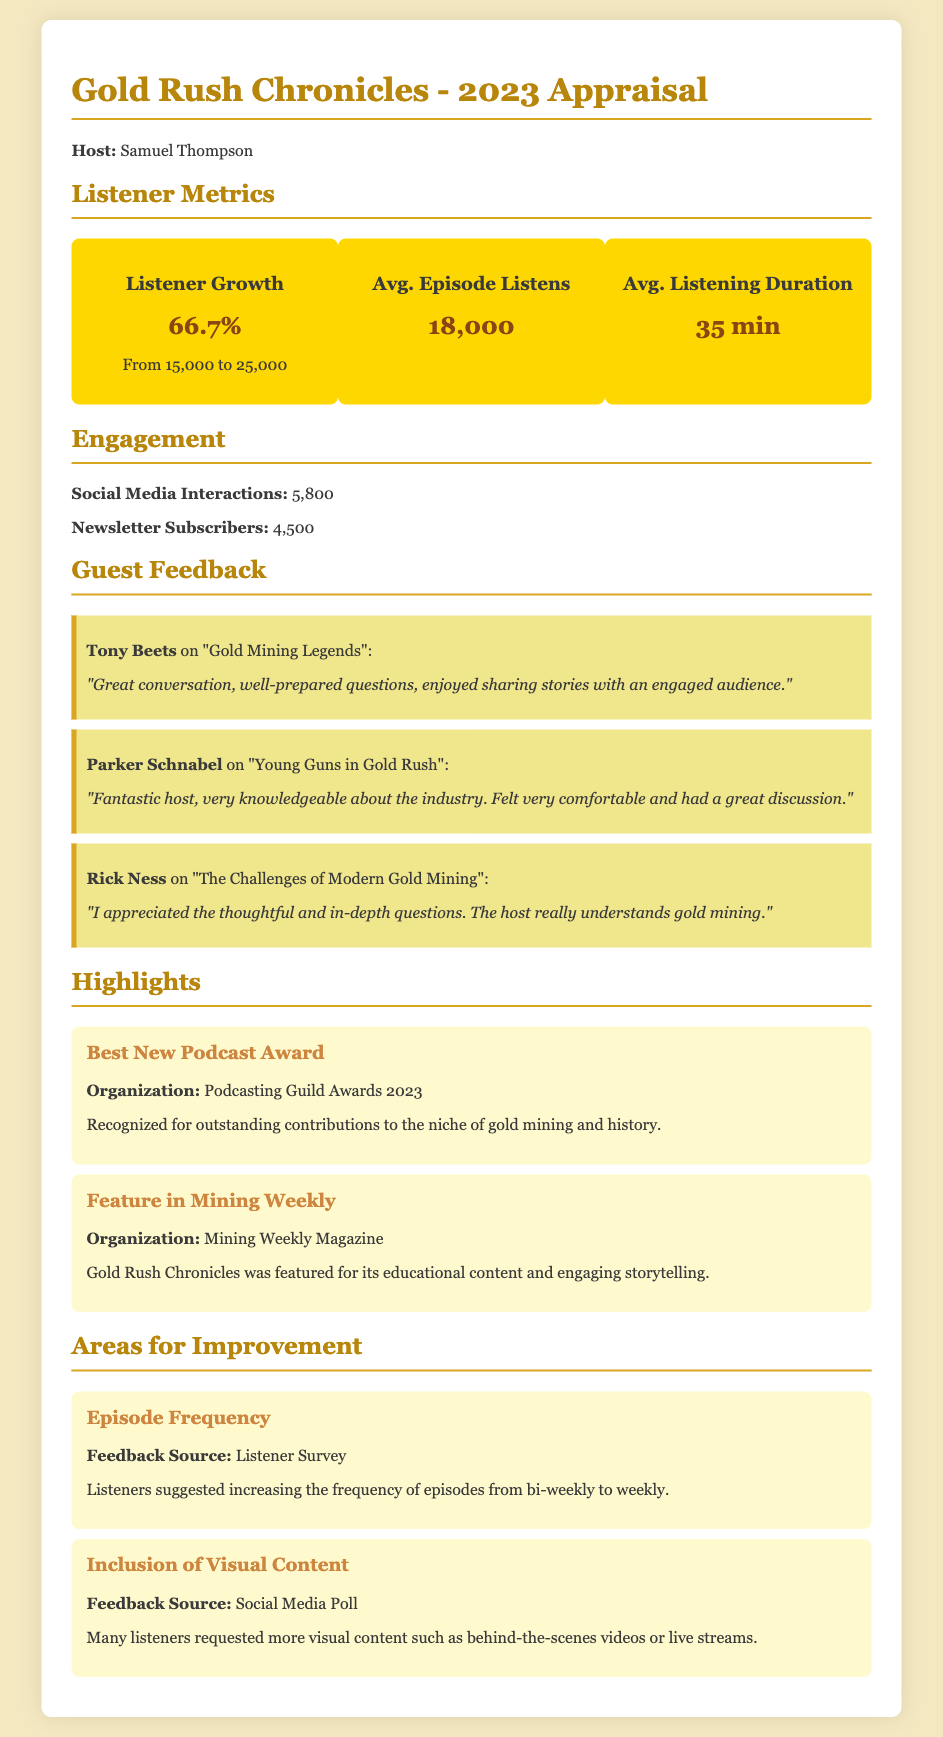What was the listener growth percentage in 2023? The listener growth percentage is shown as the increase from 15,000 to 25,000, which is 66.7%.
Answer: 66.7% How many average episode listens were recorded? The average episode listens metric indicates the number of times episodes were listened to on average, which is 18,000.
Answer: 18,000 What is the average listening duration per episode? The document states the average listening duration per episode as 35 minutes.
Answer: 35 min Who won the Best New Podcast Award? The document highlights that Gold Rush Chronicles received the Best New Podcast Award at the Podcasting Guild Awards 2023.
Answer: Gold Rush Chronicles What feedback did listeners provide regarding episode frequency? The document includes feedback from listeners requesting to increase the frequency of episodes from bi-weekly to weekly.
Answer: Increase frequency from bi-weekly to weekly Which guest appreciated the thoughtful questions? Rick Ness expressed appreciation for the thoughtful and in-depth questions in his feedback.
Answer: Rick Ness What was mentioned as a feature in Mining Weekly? The document notes that Gold Rush Chronicles was featured in Mining Weekly Magazine for its educational content and engaging storytelling.
Answer: Featured for educational content and engaging storytelling How many social media interactions were recorded? The document states that there were 5,800 social media interactions.
Answer: 5,800 What kind of visual content was requested by listeners? The document notes that many listeners requested more visual content such as behind-the-scenes videos or live streams.
Answer: Behind-the-scenes videos or live streams 